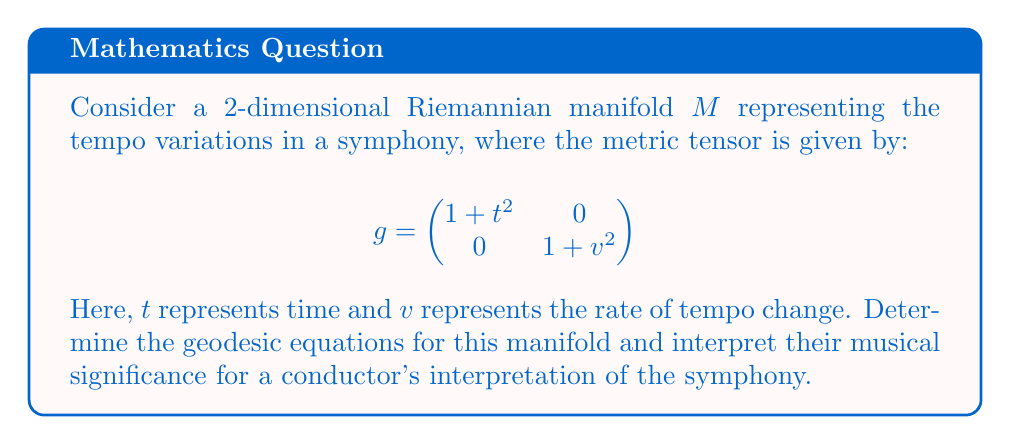Could you help me with this problem? To find the geodesic equations, we'll follow these steps:

1) First, we need to calculate the Christoffel symbols. For a metric tensor $g_{ij}$, the Christoffel symbols are given by:

   $$\Gamma^k_{ij} = \frac{1}{2}g^{kl}(\partial_i g_{jl} + \partial_j g_{il} - \partial_l g_{ij})$$

2) In our case, the non-zero components of the metric tensor are:
   
   $$g_{11} = 1 + t^2, \quad g_{22} = 1 + v^2$$

3) The inverse metric tensor is:

   $$g^{11} = \frac{1}{1+t^2}, \quad g^{22} = \frac{1}{1+v^2}$$

4) Calculating the partial derivatives:

   $$\partial_t g_{11} = 2t, \quad \partial_v g_{22} = 2v$$

   All other partial derivatives are zero.

5) Now, we can calculate the non-zero Christoffel symbols:

   $$\Gamma^1_{11} = \frac{t}{1+t^2}, \quad \Gamma^2_{22} = \frac{v}{1+v^2}$$

6) The geodesic equations are:

   $$\frac{d^2x^i}{ds^2} + \Gamma^i_{jk}\frac{dx^j}{ds}\frac{dx^k}{ds} = 0$$

   Where $s$ is the arc length parameter.

7) Substituting our Christoffel symbols, we get:

   $$\frac{d^2t}{ds^2} + \frac{t}{1+t^2}\left(\frac{dt}{ds}\right)^2 = 0$$
   $$\frac{d^2v}{ds^2} + \frac{v}{1+v^2}\left(\frac{dv}{ds}\right)^2 = 0$$

8) Musical interpretation:
   - The first equation describes how the tempo (t) changes over the course of the symphony.
   - The second equation describes how the rate of tempo change (v) evolves.
   - The nonlinear terms $\frac{t}{1+t^2}$ and $\frac{v}{1+v^2}$ suggest that larger tempo changes or rates of change tend to resist further increases, potentially representing natural limits in musical expressiveness.
   - A conductor following these geodesics would create tempo variations that are considered "natural" or "optimal" within the mathematical structure of this tempo space.
Answer: $$\frac{d^2t}{ds^2} + \frac{t}{1+t^2}\left(\frac{dt}{ds}\right)^2 = 0, \quad \frac{d^2v}{ds^2} + \frac{v}{1+v^2}\left(\frac{dv}{ds}\right)^2 = 0$$ 